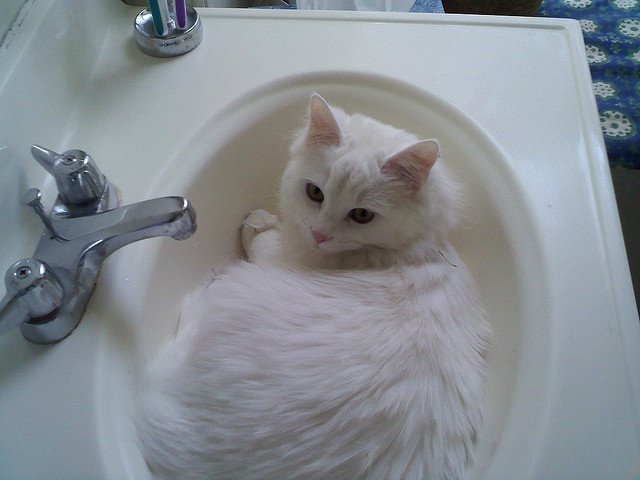Describe the objects in this image and their specific colors. I can see sink in gray, darkgray, and lightgray tones, cat in gray and darkgray tones, toothbrush in gray, darkblue, teal, and black tones, and toothbrush in gray and navy tones in this image. 